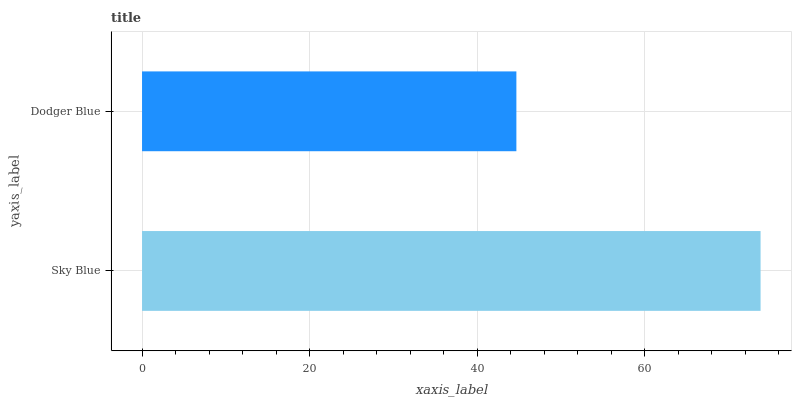Is Dodger Blue the minimum?
Answer yes or no. Yes. Is Sky Blue the maximum?
Answer yes or no. Yes. Is Dodger Blue the maximum?
Answer yes or no. No. Is Sky Blue greater than Dodger Blue?
Answer yes or no. Yes. Is Dodger Blue less than Sky Blue?
Answer yes or no. Yes. Is Dodger Blue greater than Sky Blue?
Answer yes or no. No. Is Sky Blue less than Dodger Blue?
Answer yes or no. No. Is Sky Blue the high median?
Answer yes or no. Yes. Is Dodger Blue the low median?
Answer yes or no. Yes. Is Dodger Blue the high median?
Answer yes or no. No. Is Sky Blue the low median?
Answer yes or no. No. 